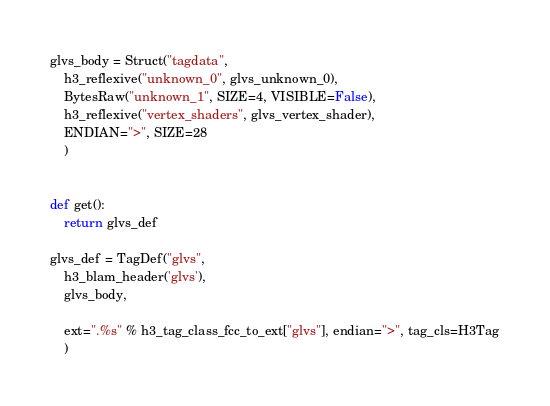Convert code to text. <code><loc_0><loc_0><loc_500><loc_500><_Python_>

glvs_body = Struct("tagdata", 
    h3_reflexive("unknown_0", glvs_unknown_0),
    BytesRaw("unknown_1", SIZE=4, VISIBLE=False),
    h3_reflexive("vertex_shaders", glvs_vertex_shader),
    ENDIAN=">", SIZE=28
    )


def get():
    return glvs_def

glvs_def = TagDef("glvs",
    h3_blam_header('glvs'),
    glvs_body,

    ext=".%s" % h3_tag_class_fcc_to_ext["glvs"], endian=">", tag_cls=H3Tag
    )</code> 